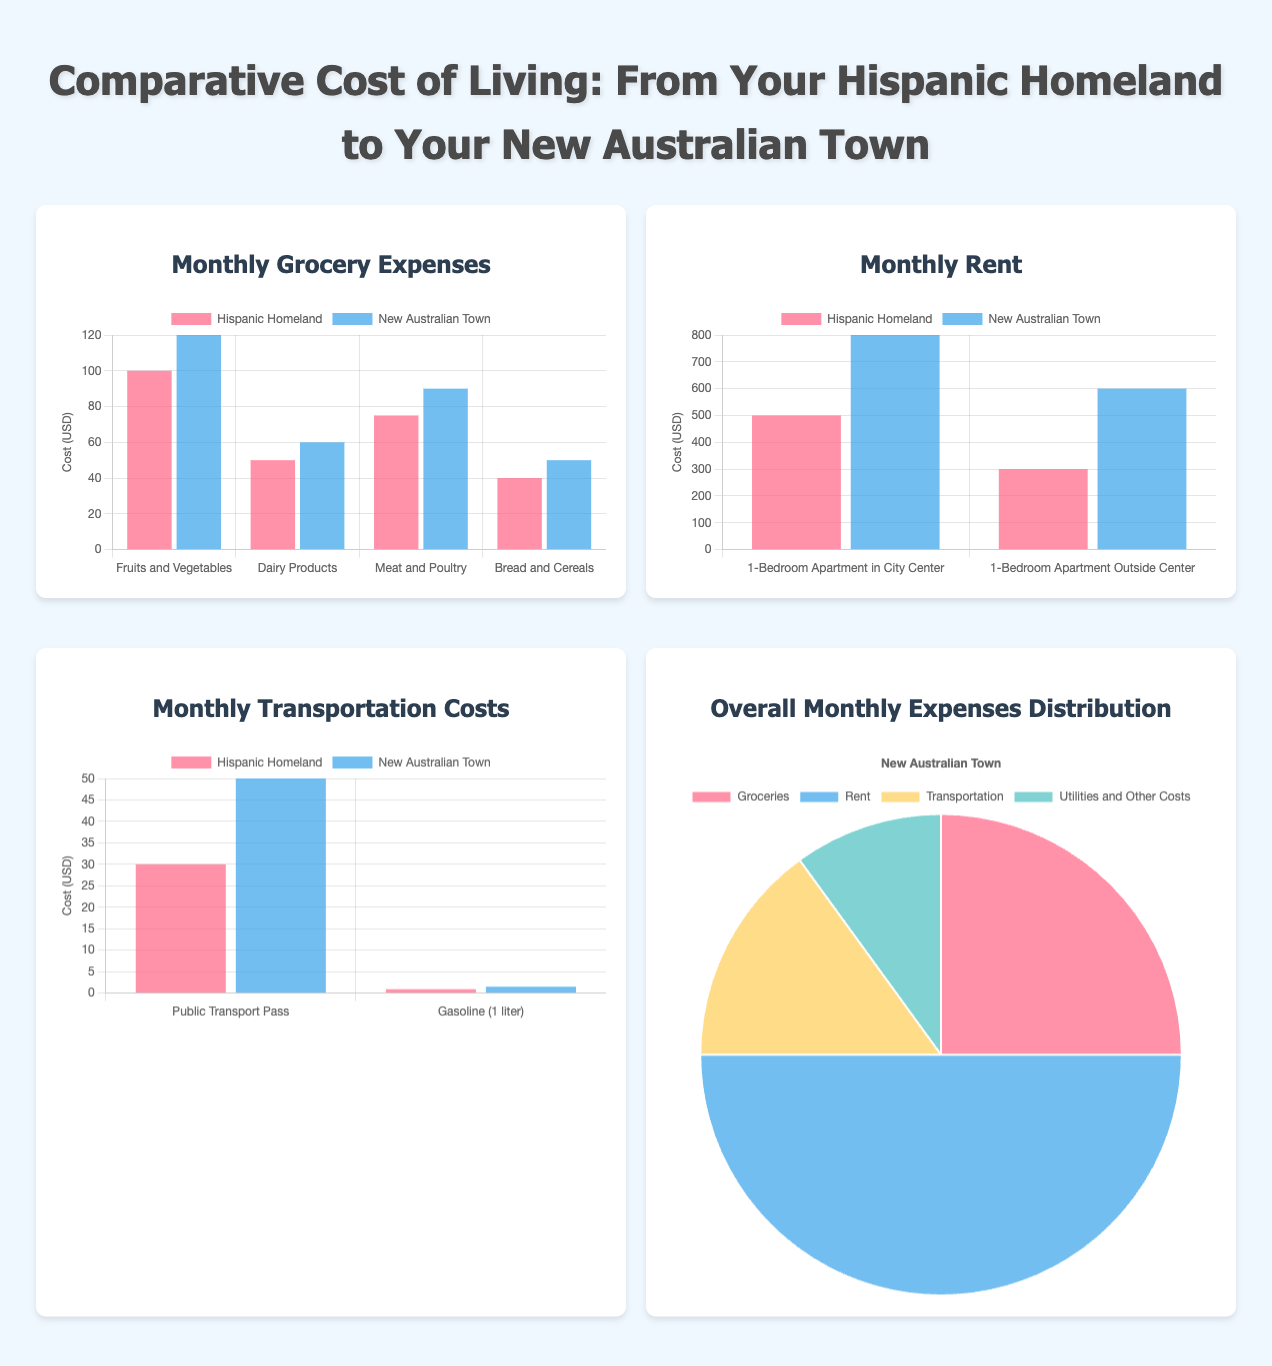what are the monthly grocery expenses for dairy products in the Hispanic homeland? The document shows that the monthly grocery expense for dairy products in the Hispanic homeland is $50.
Answer: $50 what is the cost of gasoline per liter in the New Australian Town? The document states that the cost of gasoline in the New Australian Town is $1.50 per liter.
Answer: $1.50 how much does a 1-bedroom apartment cost outside the city center in the Hispanic homeland? According to the document, a 1-bedroom apartment outside the city center in the Hispanic homeland costs $300.
Answer: $300 what is the total percentage of expenses for groceries in the New Australian Town? The document indicates that groceries account for 25% of overall monthly expenses in the New Australian Town.
Answer: 25% which category has the highest expense in the New Australian Town? The document specifies that rent has the highest expense at $800 in the New Australian Town.
Answer: Rent what is the combined cost of fruits and vegetables for the Hispanic homeland and the New Australian Town? In the document, the combined cost is the sum of $100 for the Hispanic homeland and $120 for the New Australian Town, totaling $220.
Answer: $220 how many categories are compared in the monthly grocery expenses chart? The document shows there are four categories compared in the monthly grocery expenses chart.
Answer: Four what is the total monthly rent for a 1-bedroom apartment in the city center in the New Australian Town? The document mentions that the rent for a 1-bedroom apartment in the city center in the New Australian Town is $800.
Answer: $800 which type of transportation cost is higher in the New Australian Town? The document shows that the public transport pass costs more in the New Australian Town, where it is $50 compared to $30 in the Hispanic homeland.
Answer: Public Transport Pass 